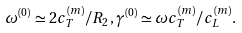<formula> <loc_0><loc_0><loc_500><loc_500>\omega ^ { ( 0 ) } \simeq 2 c _ { T } ^ { ( m ) } / R _ { 2 } , \gamma ^ { ( 0 ) } \simeq \omega c _ { T } ^ { ( m ) } / c _ { L } ^ { ( m ) } .</formula> 